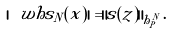<formula> <loc_0><loc_0><loc_500><loc_500>| \ w h { s } _ { N } ( x ) | = \| s ( z ) \| _ { h _ { P } ^ { N } } \, .</formula> 